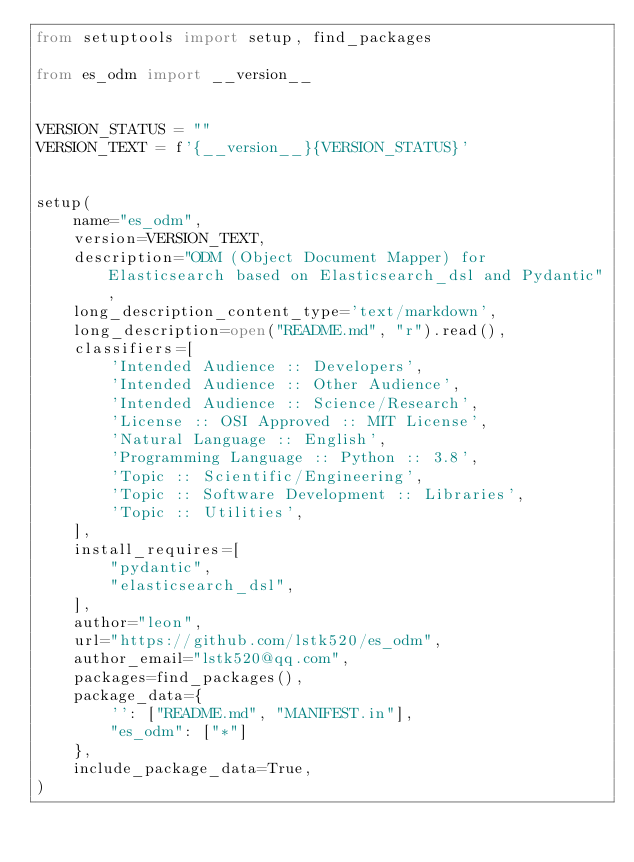Convert code to text. <code><loc_0><loc_0><loc_500><loc_500><_Python_>from setuptools import setup, find_packages

from es_odm import __version__


VERSION_STATUS = ""
VERSION_TEXT = f'{__version__}{VERSION_STATUS}'


setup(
    name="es_odm",
    version=VERSION_TEXT,
    description="ODM (Object Document Mapper) for Elasticsearch based on Elasticsearch_dsl and Pydantic",
    long_description_content_type='text/markdown',
    long_description=open("README.md", "r").read(),
    classifiers=[
        'Intended Audience :: Developers',
        'Intended Audience :: Other Audience',
        'Intended Audience :: Science/Research',
        'License :: OSI Approved :: MIT License',
        'Natural Language :: English',
        'Programming Language :: Python :: 3.8',
        'Topic :: Scientific/Engineering',
        'Topic :: Software Development :: Libraries',
        'Topic :: Utilities',
    ],
    install_requires=[
        "pydantic",
        "elasticsearch_dsl",
    ],
    author="leon",
    url="https://github.com/lstk520/es_odm",
    author_email="lstk520@qq.com",
    packages=find_packages(),
    package_data={
        '': ["README.md", "MANIFEST.in"],
        "es_odm": ["*"]
    },
    include_package_data=True,
)
</code> 